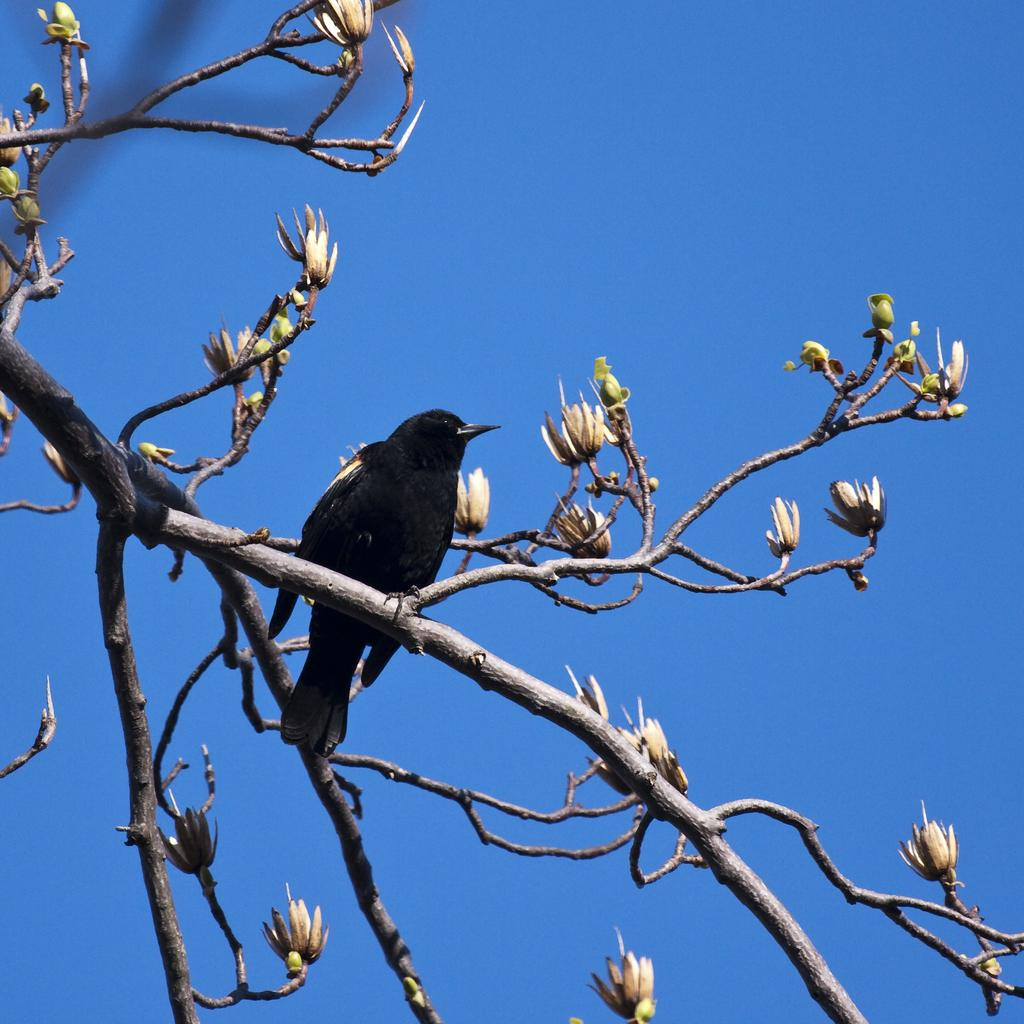What type of animal is in the image? There is a bird in the image. What color is the bird? The bird is black in color. Where is the bird located in the image? The bird is on the stem of a tree. What other elements can be seen in the image besides the bird? There are flowers in the image. What can be seen in the background of the image? The sky is visible in the background of the image. What is the color of the sky? The sky is blue in color. Where is the cup placed in the image? There is no cup present in the image. Can you describe the squirrel's behavior in the image? There is no squirrel present in the image. 